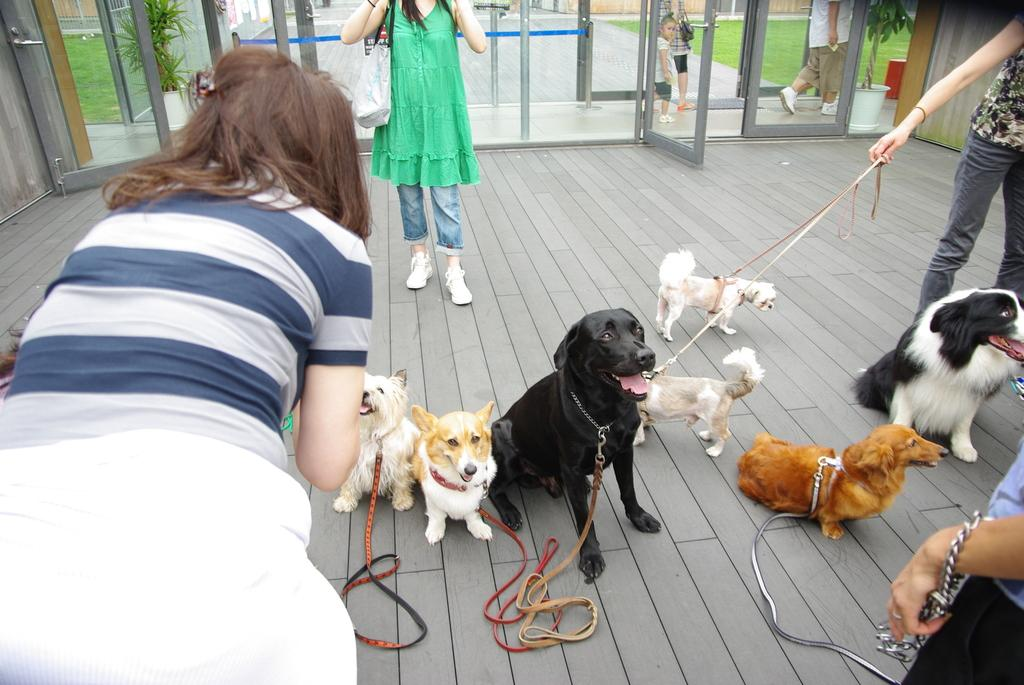Who or what can be seen in the image? There are people and dogs in the image. What is the dogs' location in the image? The dogs are on the ground in the image. What can be seen in the background of the image? There are plants and grass visible in the background of the image. How many baskets are being used by the people in the image? There is no mention of baskets in the image, so we cannot determine how many are being used. 